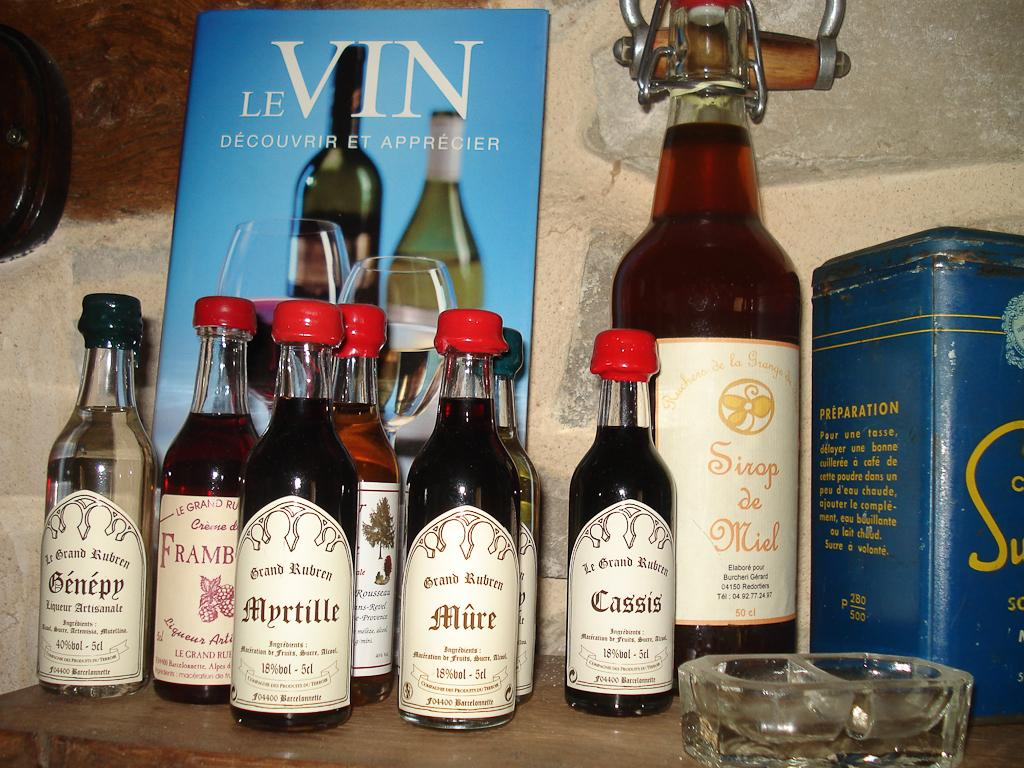<image>
Describe the image concisely. A bunch of bottles in front of a card that reads "Le Vin" 